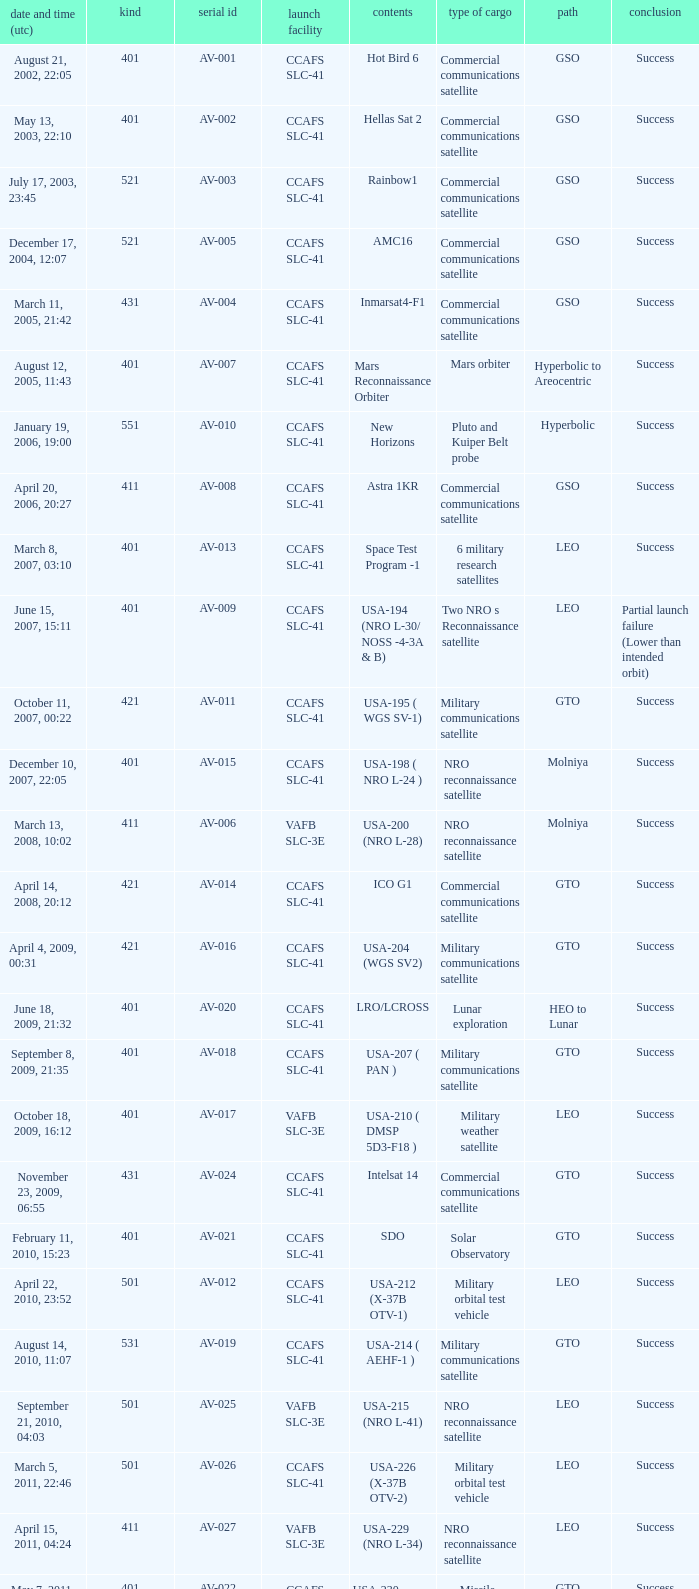When was the payload of Commercial Communications Satellite amc16? December 17, 2004, 12:07. 